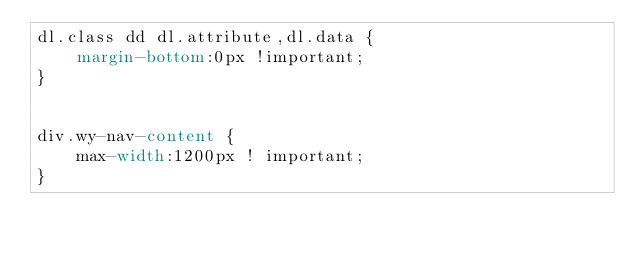Convert code to text. <code><loc_0><loc_0><loc_500><loc_500><_CSS_>dl.class dd dl.attribute,dl.data {
	margin-bottom:0px !important;
}


div.wy-nav-content {
	max-width:1200px ! important;
}</code> 